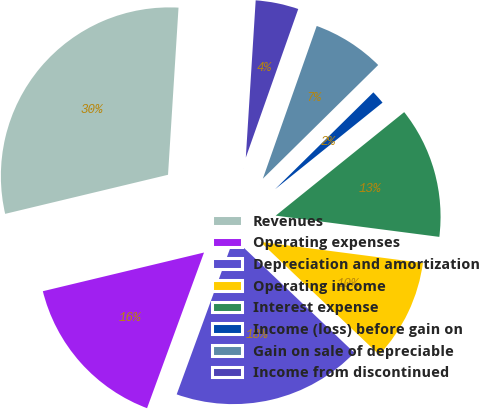Convert chart. <chart><loc_0><loc_0><loc_500><loc_500><pie_chart><fcel>Revenues<fcel>Operating expenses<fcel>Depreciation and amortization<fcel>Operating income<fcel>Interest expense<fcel>Income (loss) before gain on<fcel>Gain on sale of depreciable<fcel>Income from discontinued<nl><fcel>29.75%<fcel>15.67%<fcel>18.49%<fcel>10.04%<fcel>12.85%<fcel>1.59%<fcel>7.22%<fcel>4.4%<nl></chart> 